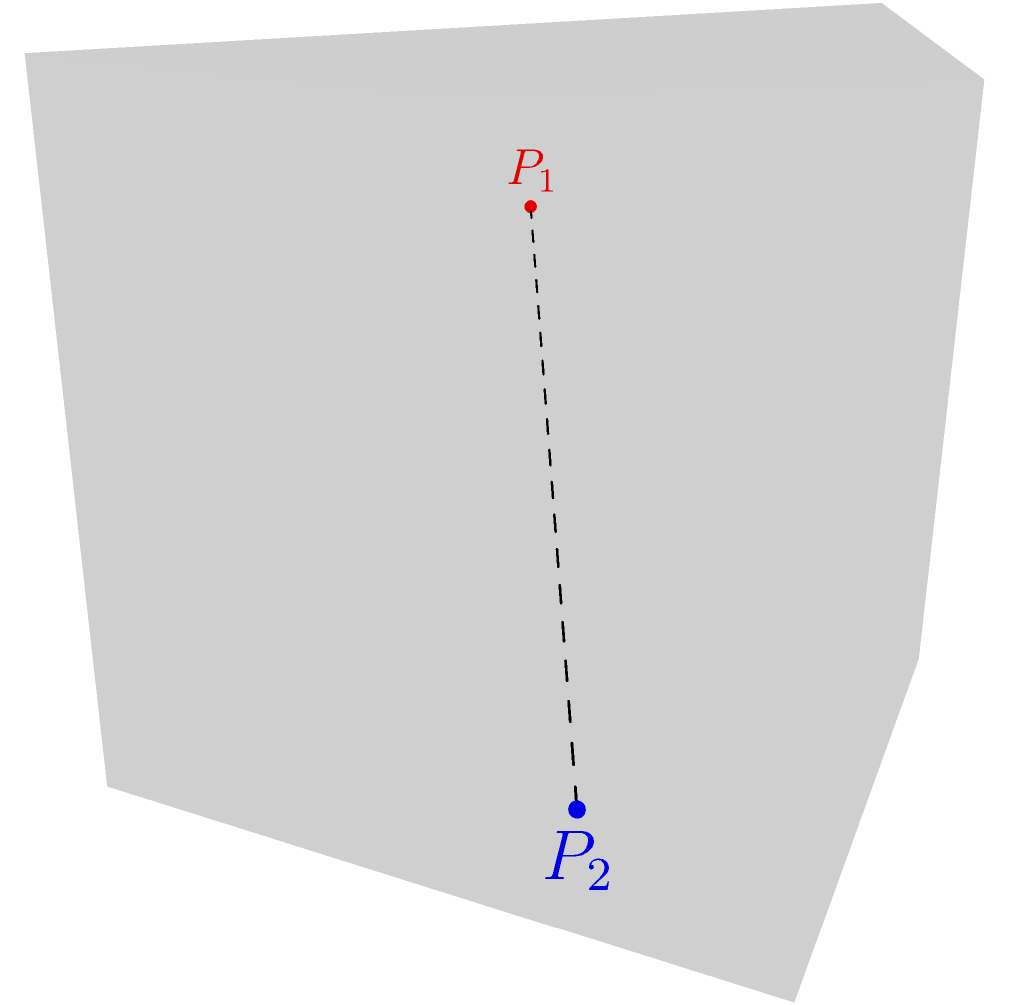In a late-night gaming session, you and your friend are exploring a 3D world. Your character's position is at $P_1(2, 3, 8)$, while your friend's character is at $P_2(9, 7, 1)$. Calculate the straight-line distance between your characters using the 3D distance formula. To find the distance between two points in 3D space, we use the distance formula:

$$d = \sqrt{(x_2-x_1)^2 + (y_2-y_1)^2 + (z_2-z_1)^2}$$

Where $(x_1, y_1, z_1)$ are the coordinates of $P_1$ and $(x_2, y_2, z_2)$ are the coordinates of $P_2$.

Step 1: Identify the coordinates
$P_1(x_1, y_1, z_1) = (2, 3, 8)$
$P_2(x_2, y_2, z_2) = (9, 7, 1)$

Step 2: Calculate the differences
$x_2 - x_1 = 9 - 2 = 7$
$y_2 - y_1 = 7 - 3 = 4$
$z_2 - z_1 = 1 - 8 = -7$

Step 3: Square the differences
$(x_2-x_1)^2 = 7^2 = 49$
$(y_2-y_1)^2 = 4^2 = 16$
$(z_2-z_1)^2 = (-7)^2 = 49$

Step 4: Sum the squared differences
$49 + 16 + 49 = 114$

Step 5: Calculate the square root
$d = \sqrt{114} \approx 10.68$ units

Therefore, the distance between your characters is approximately 10.68 units in the game world.
Answer: $\sqrt{114} \approx 10.68$ units 